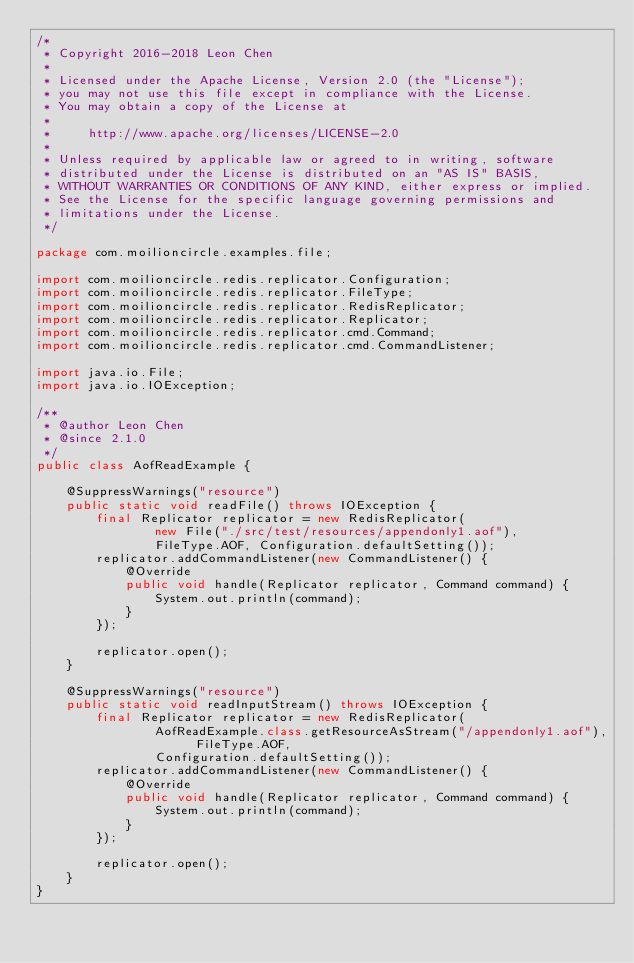Convert code to text. <code><loc_0><loc_0><loc_500><loc_500><_Java_>/*
 * Copyright 2016-2018 Leon Chen
 *
 * Licensed under the Apache License, Version 2.0 (the "License");
 * you may not use this file except in compliance with the License.
 * You may obtain a copy of the License at
 *
 *     http://www.apache.org/licenses/LICENSE-2.0
 *
 * Unless required by applicable law or agreed to in writing, software
 * distributed under the License is distributed on an "AS IS" BASIS,
 * WITHOUT WARRANTIES OR CONDITIONS OF ANY KIND, either express or implied.
 * See the License for the specific language governing permissions and
 * limitations under the License.
 */

package com.moilioncircle.examples.file;

import com.moilioncircle.redis.replicator.Configuration;
import com.moilioncircle.redis.replicator.FileType;
import com.moilioncircle.redis.replicator.RedisReplicator;
import com.moilioncircle.redis.replicator.Replicator;
import com.moilioncircle.redis.replicator.cmd.Command;
import com.moilioncircle.redis.replicator.cmd.CommandListener;

import java.io.File;
import java.io.IOException;

/**
 * @author Leon Chen
 * @since 2.1.0
 */
public class AofReadExample {

    @SuppressWarnings("resource")
    public static void readFile() throws IOException {
        final Replicator replicator = new RedisReplicator(
                new File("./src/test/resources/appendonly1.aof"),
                FileType.AOF, Configuration.defaultSetting());
        replicator.addCommandListener(new CommandListener() {
            @Override
            public void handle(Replicator replicator, Command command) {
                System.out.println(command);
            }
        });

        replicator.open();
    }

    @SuppressWarnings("resource")
    public static void readInputStream() throws IOException {
        final Replicator replicator = new RedisReplicator(
                AofReadExample.class.getResourceAsStream("/appendonly1.aof"), FileType.AOF,
                Configuration.defaultSetting());
        replicator.addCommandListener(new CommandListener() {
            @Override
            public void handle(Replicator replicator, Command command) {
                System.out.println(command);
            }
        });

        replicator.open();
    }
}
</code> 